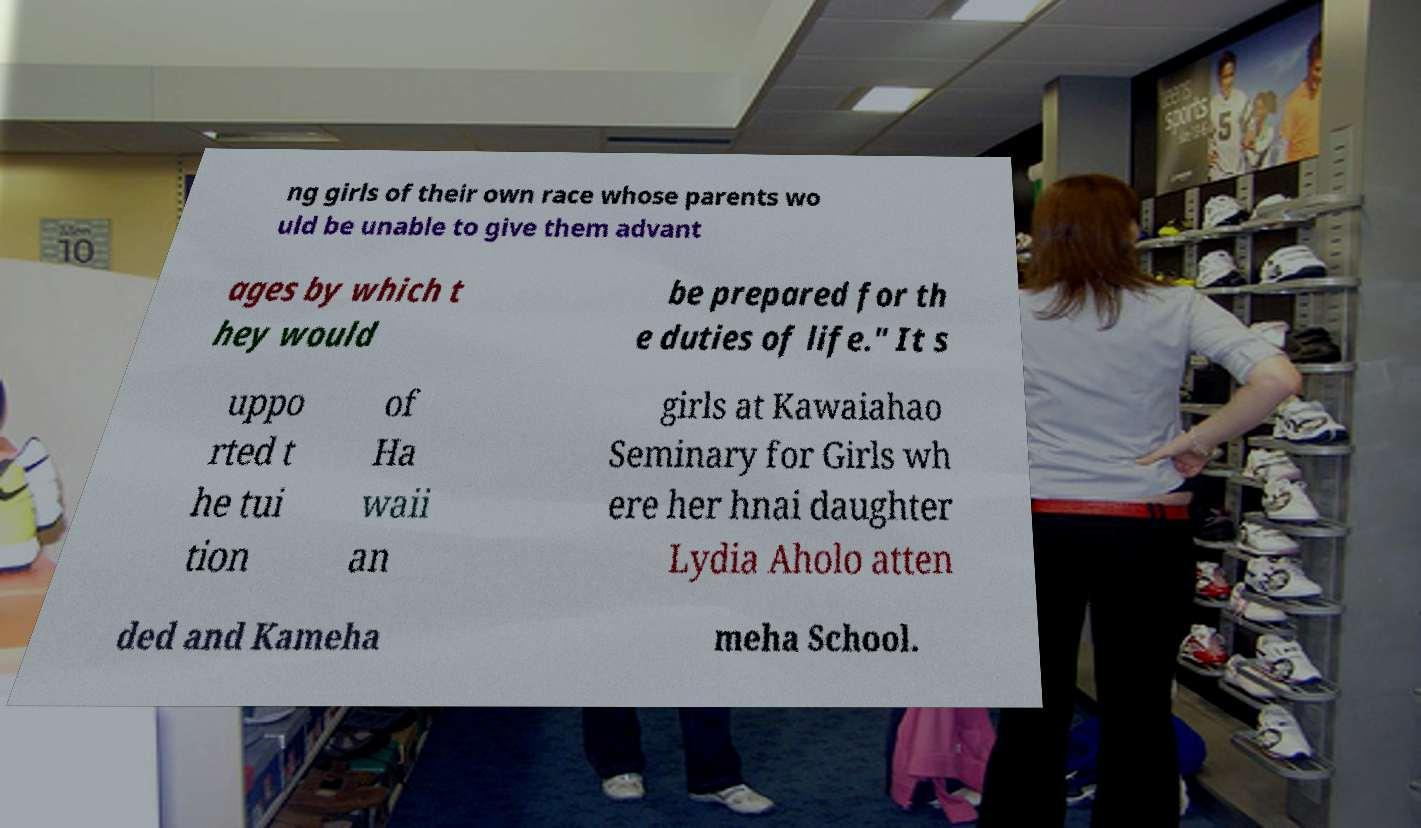Please identify and transcribe the text found in this image. ng girls of their own race whose parents wo uld be unable to give them advant ages by which t hey would be prepared for th e duties of life." It s uppo rted t he tui tion of Ha waii an girls at Kawaiahao Seminary for Girls wh ere her hnai daughter Lydia Aholo atten ded and Kameha meha School. 